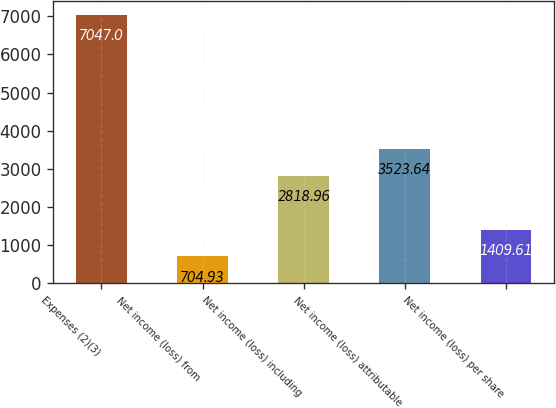<chart> <loc_0><loc_0><loc_500><loc_500><bar_chart><fcel>Expenses (2)(3)<fcel>Net income (loss) from<fcel>Net income (loss) including<fcel>Net income (loss) attributable<fcel>Net income (loss) per share<nl><fcel>7047<fcel>704.93<fcel>2818.96<fcel>3523.64<fcel>1409.61<nl></chart> 